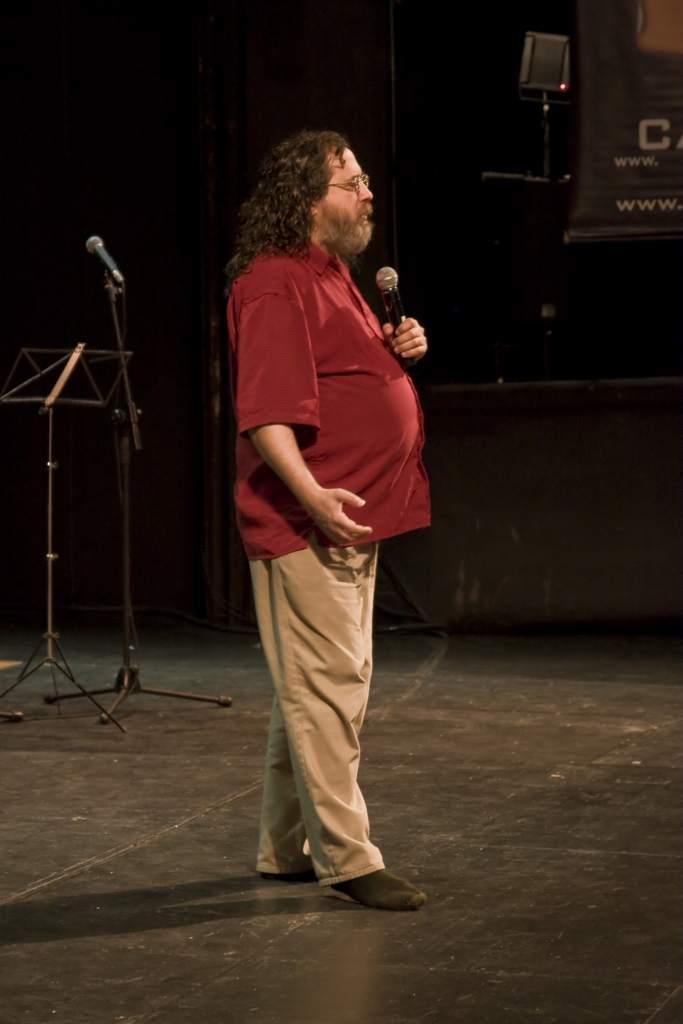What is the man in the image holding? The man is holding a mic. Where is the man standing in the image? The man is standing on the floor. What can be seen in the background of the image? There is a stand and a mic stand in the background of the image. What is present on the right side top of the image? There is a banner on the right side top of the image. How many trees can be seen in the image? There are no trees visible in the image. What type of smash is the man performing in the image? There is no smash being performed in the image; the man is simply holding a mic. 